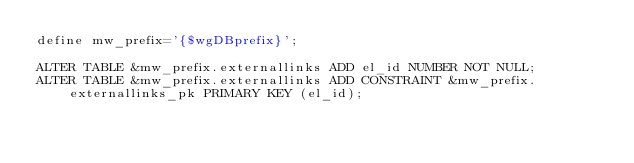<code> <loc_0><loc_0><loc_500><loc_500><_SQL_>define mw_prefix='{$wgDBprefix}';

ALTER TABLE &mw_prefix.externallinks ADD el_id NUMBER NOT NULL;
ALTER TABLE &mw_prefix.externallinks ADD CONSTRAINT &mw_prefix.externallinks_pk PRIMARY KEY (el_id);</code> 